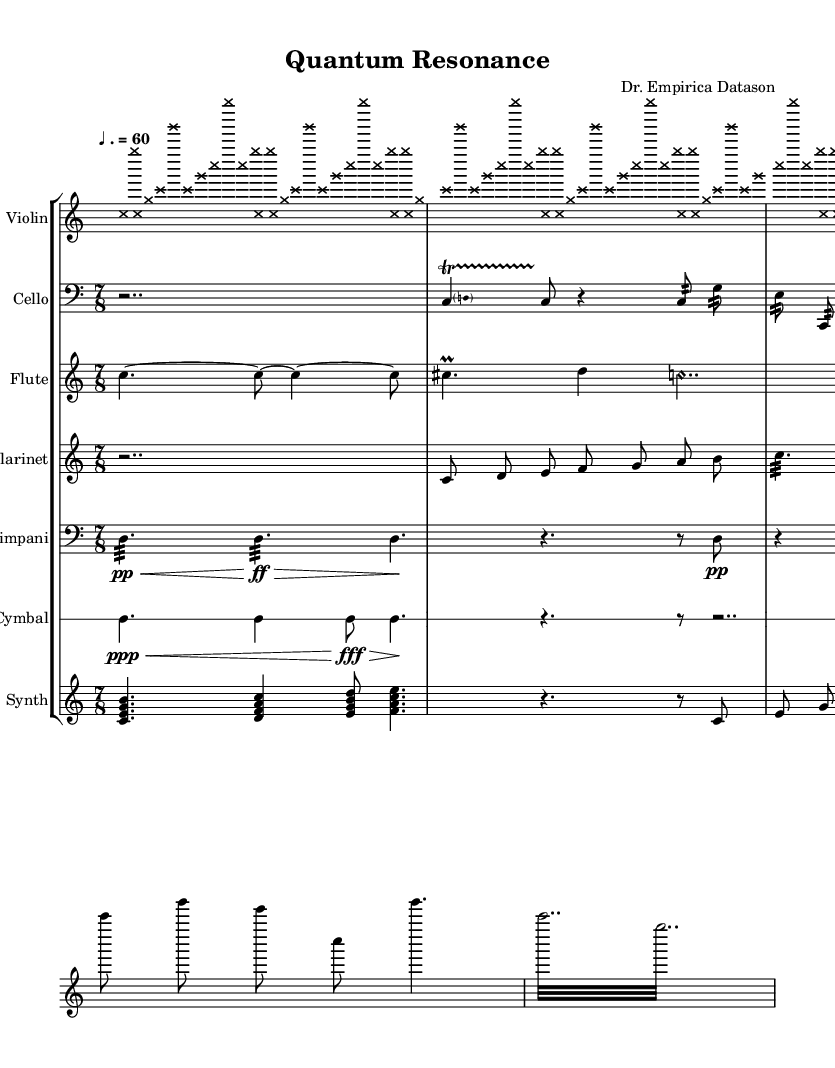What is the time signature of this music? The time signature is located at the beginning of the score, represented as 7/8, indicating seven beats in a measure, with an eighth note as the beat unit.
Answer: 7/8 What is the tempo marking in this piece? The tempo marking is indicated at the beginning of the score as "♩. = 60," which means the quarter note should be played at a speed of 60 beats per minute.
Answer: 60 Which instrument has a clef marked as "bass"? The cello part is marked with the bass clef, indicating that it plays lower pitches compared to other instruments in the score, allowing recognition at a glance.
Answer: Cello How many measures does the violin part repeat? The violin part indicates a section with a repeat sign marked as "repeat unfold 7" at the beginning of the passage, meaning that it repeats this section for seven measures.
Answer: 7 What technique is used in the cello part? The cello part prominently features a trill notated with the symbols "c4\startTrillSpan d c8\stopTrillSpan," which indicates a rapid alternation between the pitches C and D.
Answer: Trill Which instrument uses harmomic note heads? The flute part specifies the use of harmonic note heads, evident by the notation "NoteHead.style = #'harmonic" in the code, which is a technique that produces ethereal sounds.
Answer: Flute What kind of rhythm is used extensively in the timpani part? The timpani part features a mix of different rhythmic values, with notable use of silence and rests, as seen in the sequences of written rests and note durations.
Answer: Silence 